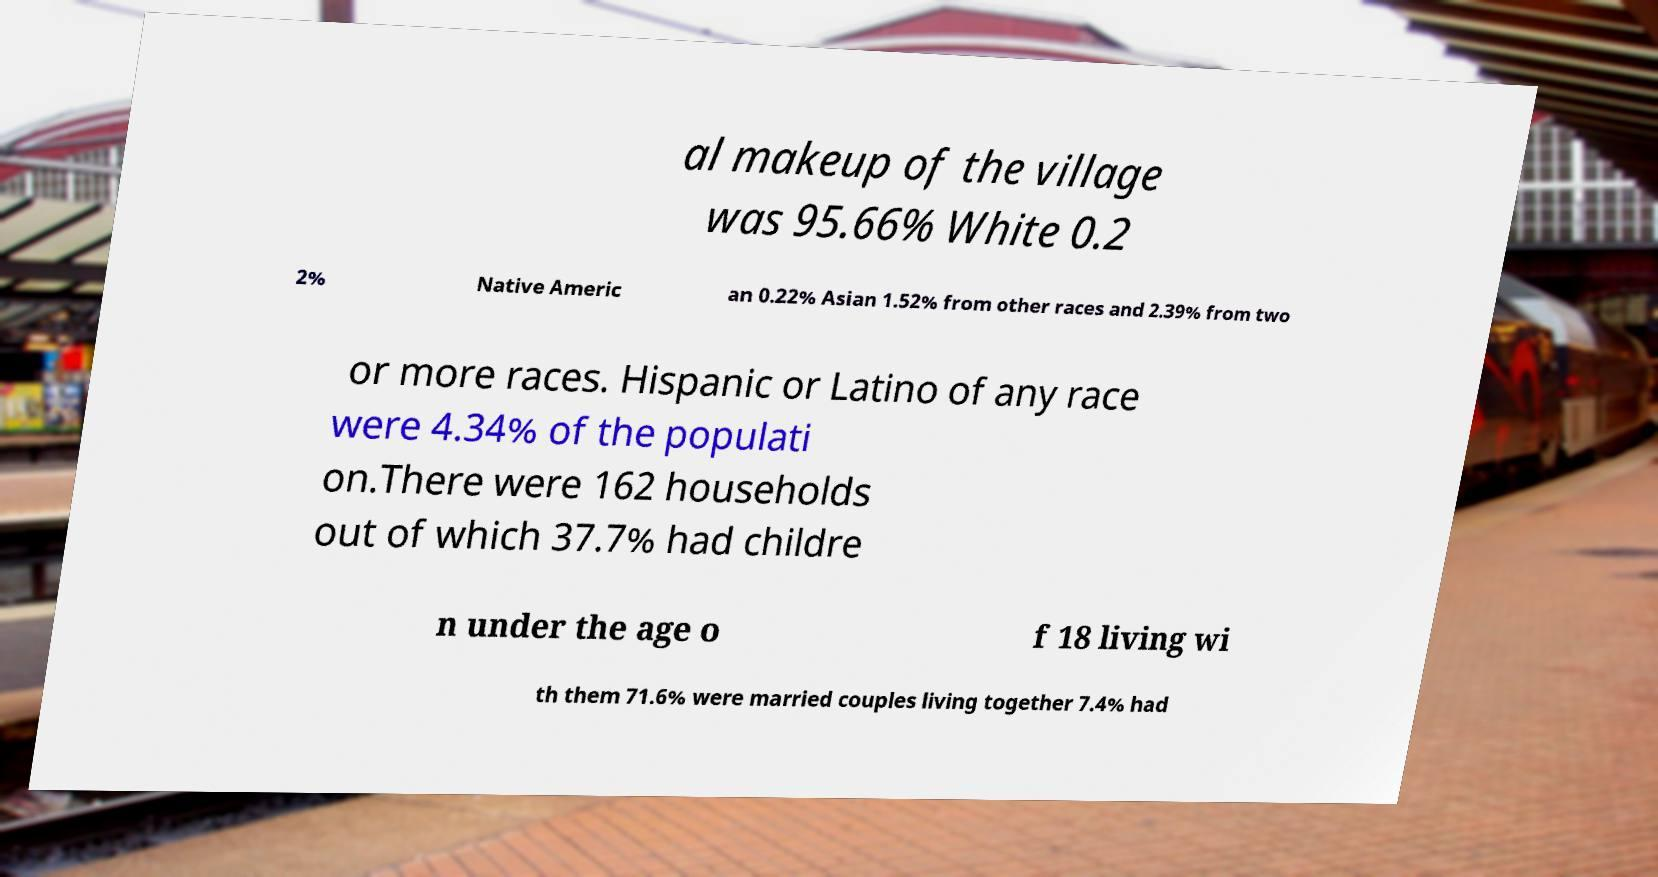Could you assist in decoding the text presented in this image and type it out clearly? al makeup of the village was 95.66% White 0.2 2% Native Americ an 0.22% Asian 1.52% from other races and 2.39% from two or more races. Hispanic or Latino of any race were 4.34% of the populati on.There were 162 households out of which 37.7% had childre n under the age o f 18 living wi th them 71.6% were married couples living together 7.4% had 